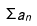<formula> <loc_0><loc_0><loc_500><loc_500>\Sigma a _ { n }</formula> 